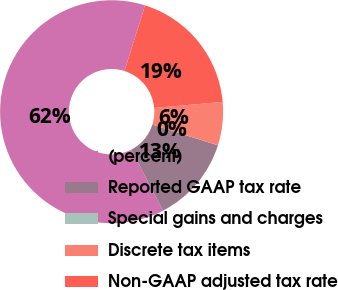Convert chart. <chart><loc_0><loc_0><loc_500><loc_500><pie_chart><fcel>(percent)<fcel>Reported GAAP tax rate<fcel>Special gains and charges<fcel>Discrete tax items<fcel>Non-GAAP adjusted tax rate<nl><fcel>62.47%<fcel>12.5%<fcel>0.01%<fcel>6.26%<fcel>18.75%<nl></chart> 